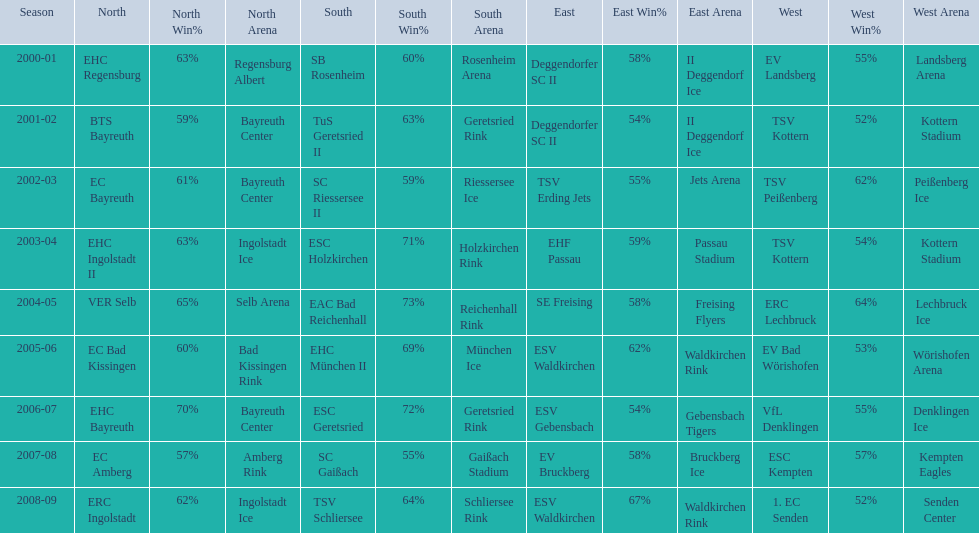Which teams played in the north? EHC Regensburg, BTS Bayreuth, EC Bayreuth, EHC Ingolstadt II, VER Selb, EC Bad Kissingen, EHC Bayreuth, EC Amberg, ERC Ingolstadt. Of these teams, which played during 2000-2001? EHC Regensburg. 